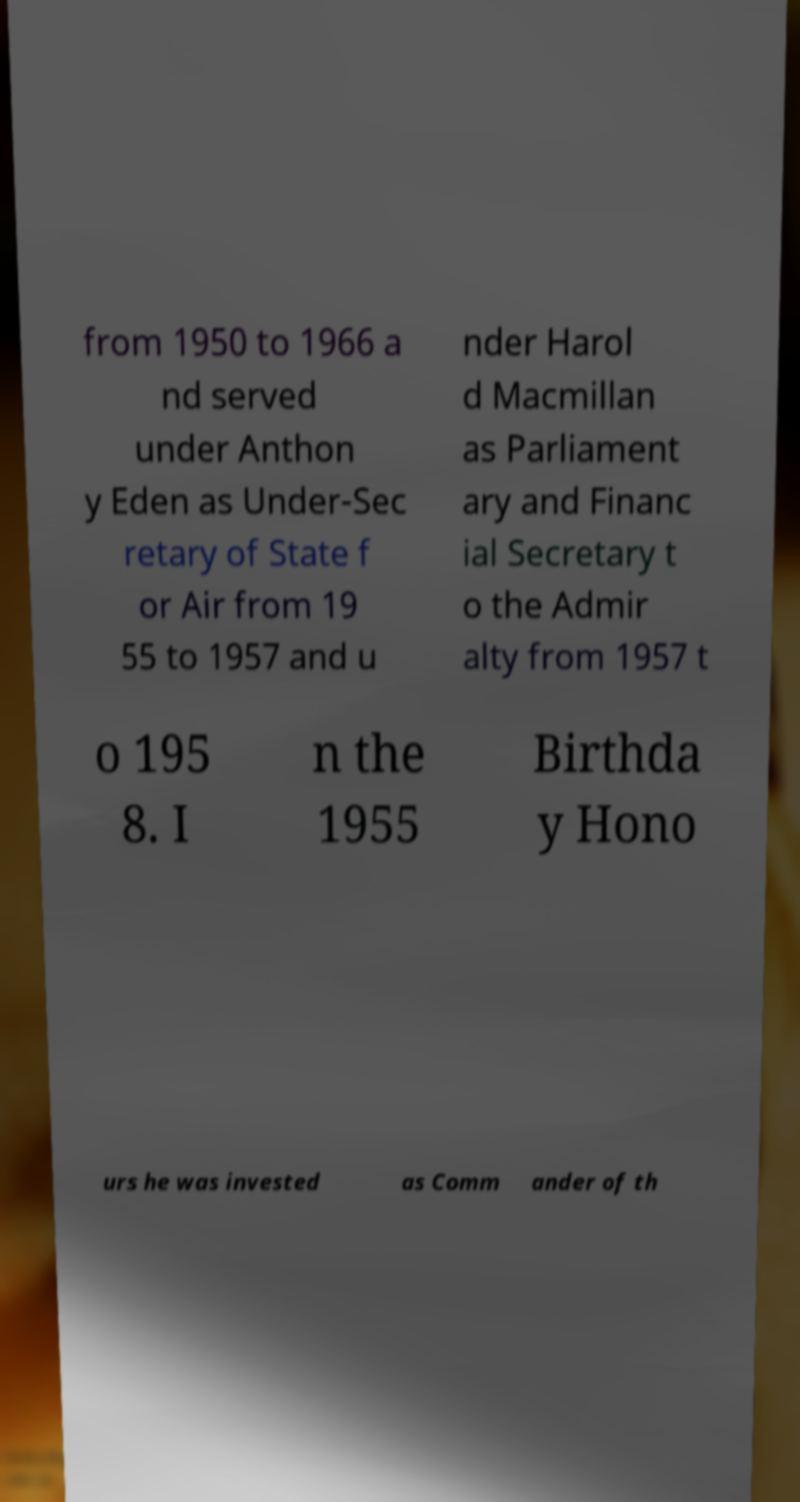What messages or text are displayed in this image? I need them in a readable, typed format. from 1950 to 1966 a nd served under Anthon y Eden as Under-Sec retary of State f or Air from 19 55 to 1957 and u nder Harol d Macmillan as Parliament ary and Financ ial Secretary t o the Admir alty from 1957 t o 195 8. I n the 1955 Birthda y Hono urs he was invested as Comm ander of th 